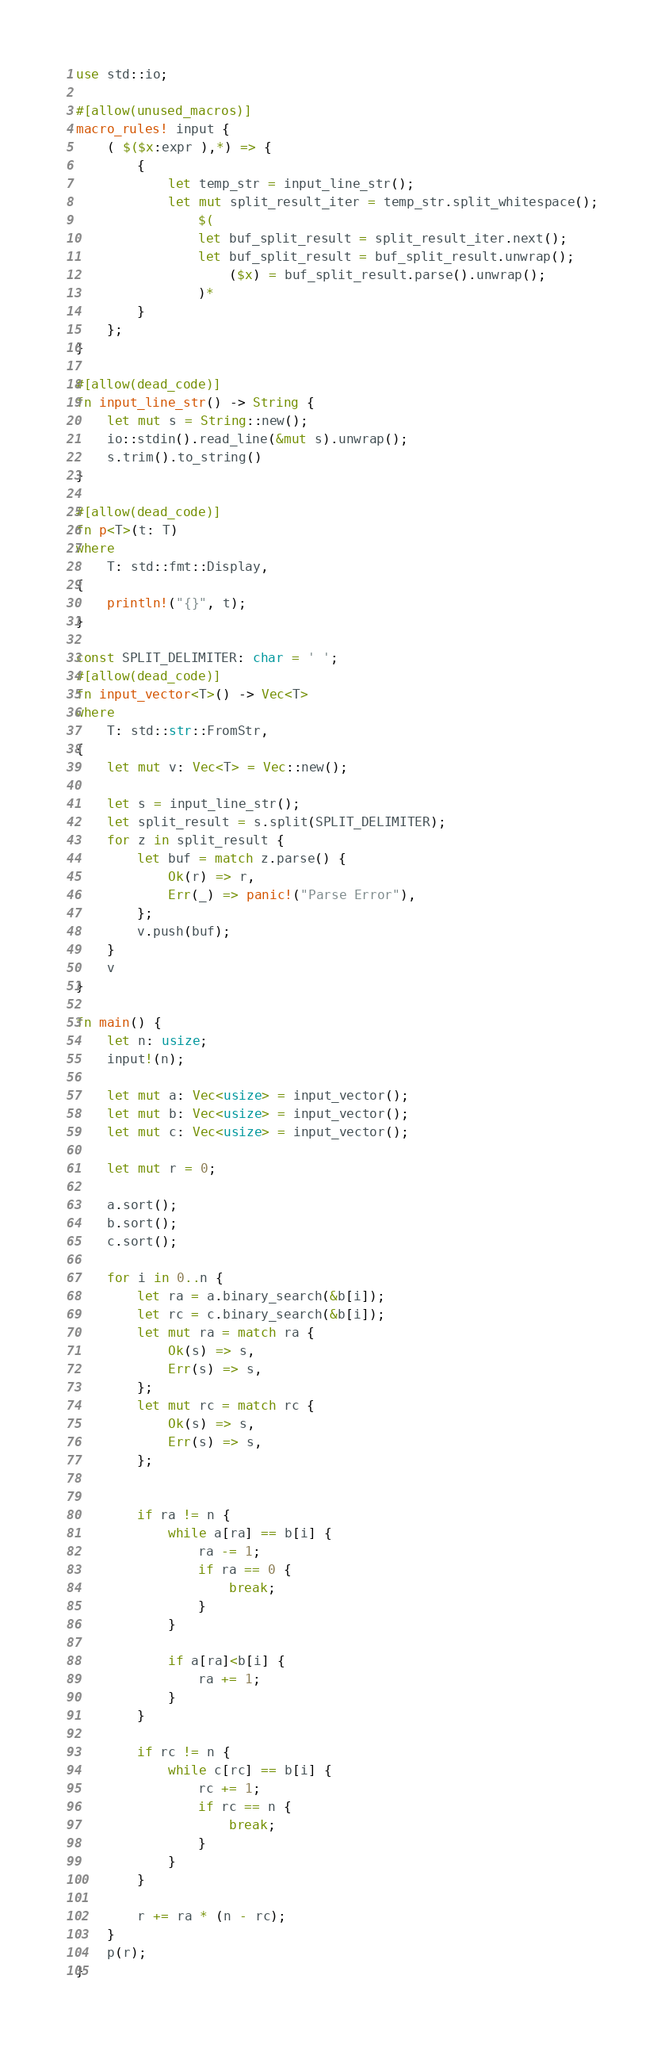<code> <loc_0><loc_0><loc_500><loc_500><_Rust_>use std::io;

#[allow(unused_macros)]
macro_rules! input {
    ( $($x:expr ),*) => {
        {
            let temp_str = input_line_str();
            let mut split_result_iter = temp_str.split_whitespace();
                $(
                let buf_split_result = split_result_iter.next();
                let buf_split_result = buf_split_result.unwrap();
                    ($x) = buf_split_result.parse().unwrap();
                )*
        }
    };
}

#[allow(dead_code)]
fn input_line_str() -> String {
    let mut s = String::new();
    io::stdin().read_line(&mut s).unwrap();
    s.trim().to_string()
}

#[allow(dead_code)]
fn p<T>(t: T)
where
    T: std::fmt::Display,
{
    println!("{}", t);
}

const SPLIT_DELIMITER: char = ' ';
#[allow(dead_code)]
fn input_vector<T>() -> Vec<T>
where
    T: std::str::FromStr,
{
    let mut v: Vec<T> = Vec::new();

    let s = input_line_str();
    let split_result = s.split(SPLIT_DELIMITER);
    for z in split_result {
        let buf = match z.parse() {
            Ok(r) => r,
            Err(_) => panic!("Parse Error"),
        };
        v.push(buf);
    }
    v
}

fn main() {
    let n: usize;
    input!(n);

    let mut a: Vec<usize> = input_vector();
    let mut b: Vec<usize> = input_vector();
    let mut c: Vec<usize> = input_vector();

    let mut r = 0;

    a.sort();
    b.sort();
    c.sort();

    for i in 0..n {
        let ra = a.binary_search(&b[i]);
        let rc = c.binary_search(&b[i]);
        let mut ra = match ra {
            Ok(s) => s,
            Err(s) => s,
        };
        let mut rc = match rc {
            Ok(s) => s,
            Err(s) => s,
        };


        if ra != n {
            while a[ra] == b[i] {
                ra -= 1;
                if ra == 0 {
                    break;
                }
            }

            if a[ra]<b[i] {
                ra += 1;
            }
        }

        if rc != n {
            while c[rc] == b[i] {
                rc += 1;
                if rc == n {
                    break;
                }
            }
        }

        r += ra * (n - rc);
    }
    p(r);
}</code> 